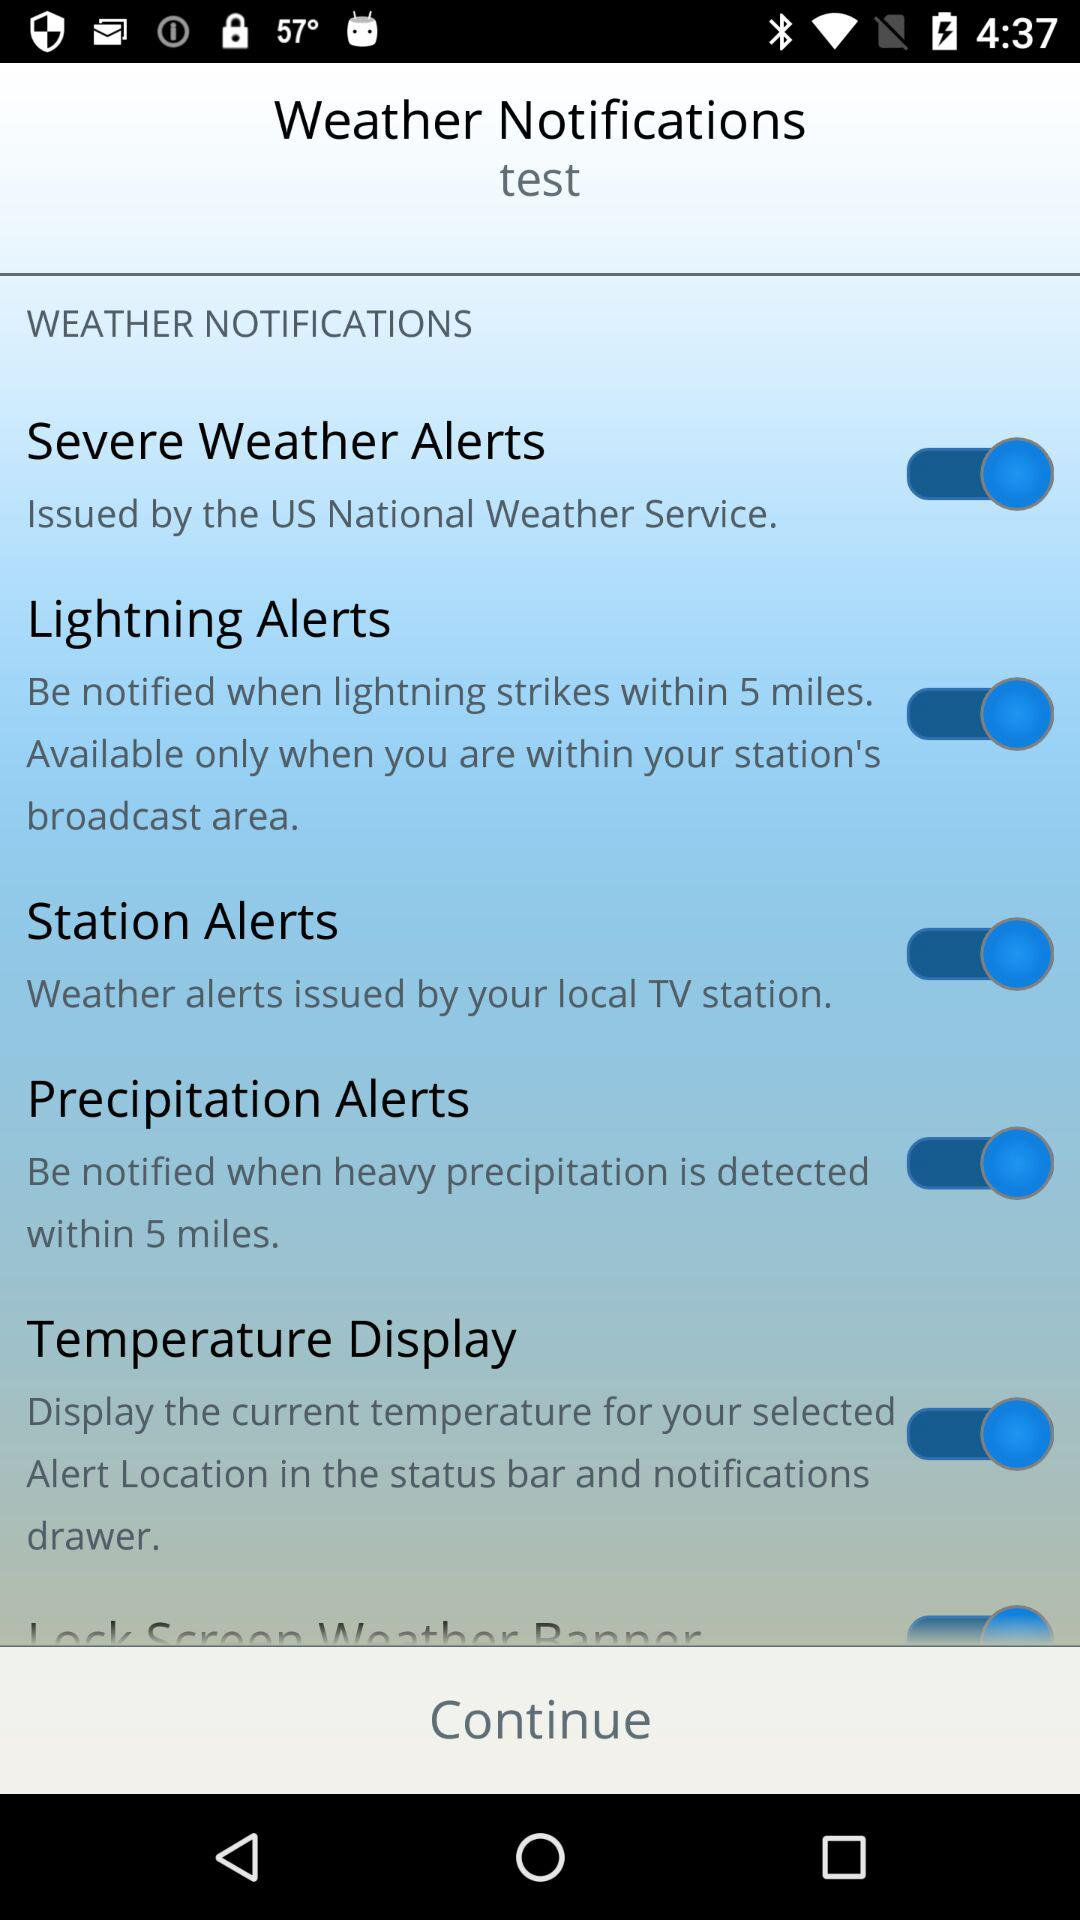What is the status of "Severe Weather Alerts"? The status is on. 